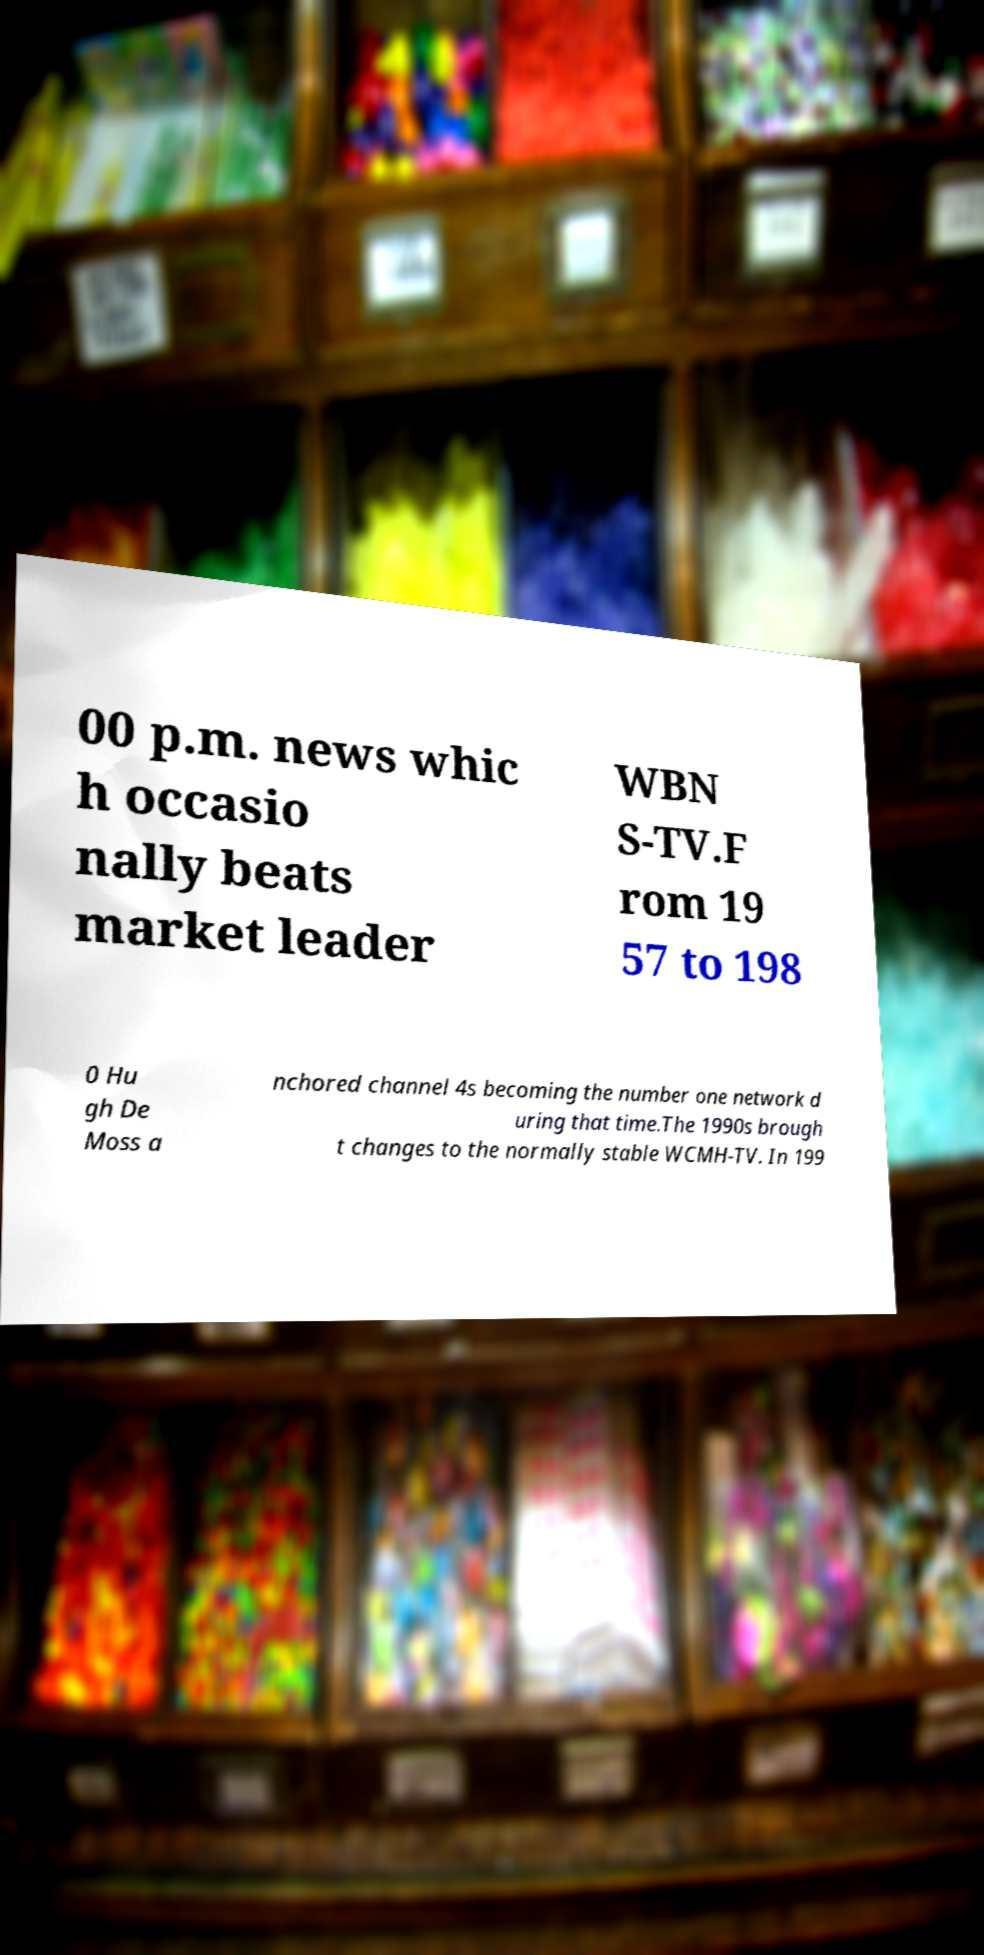Please identify and transcribe the text found in this image. 00 p.m. news whic h occasio nally beats market leader WBN S-TV.F rom 19 57 to 198 0 Hu gh De Moss a nchored channel 4s becoming the number one network d uring that time.The 1990s brough t changes to the normally stable WCMH-TV. In 199 